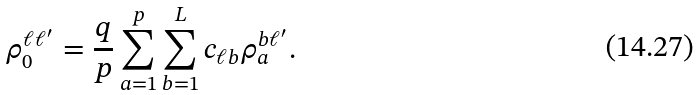<formula> <loc_0><loc_0><loc_500><loc_500>\rho ^ { \ell \ell ^ { \prime } } _ { 0 } = \frac { q } { p } \sum _ { a = 1 } ^ { p } \sum _ { b = 1 } ^ { L } c _ { \ell b } \rho ^ { b \ell ^ { \prime } } _ { a } .</formula> 